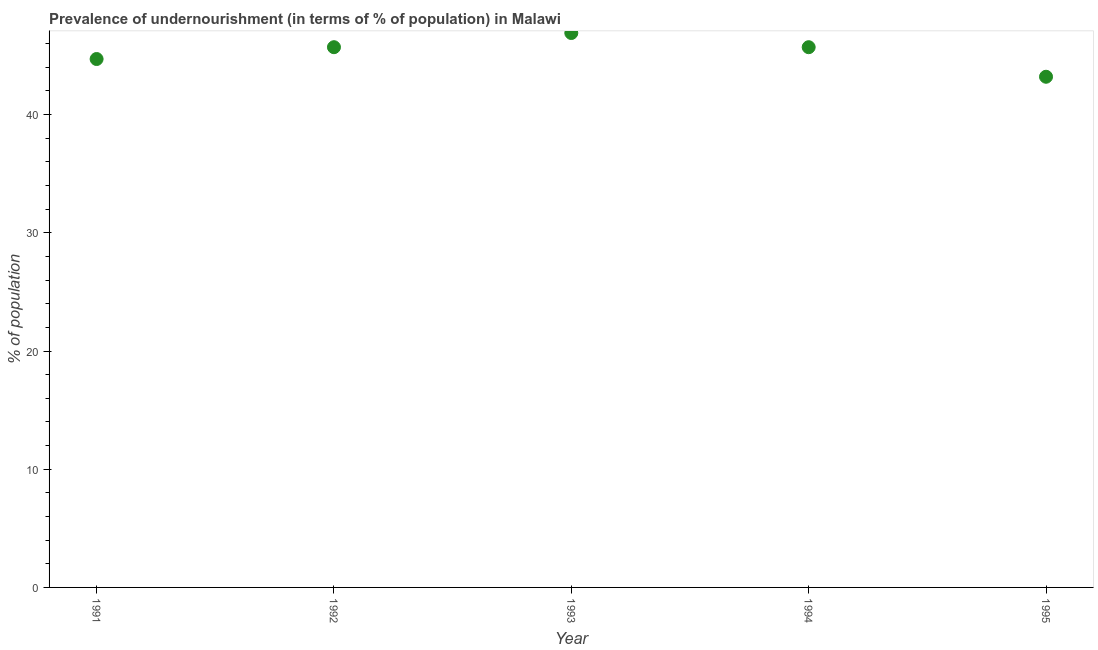What is the percentage of undernourished population in 1991?
Provide a succinct answer. 44.7. Across all years, what is the maximum percentage of undernourished population?
Offer a terse response. 46.9. Across all years, what is the minimum percentage of undernourished population?
Give a very brief answer. 43.2. In which year was the percentage of undernourished population maximum?
Offer a terse response. 1993. In which year was the percentage of undernourished population minimum?
Provide a short and direct response. 1995. What is the sum of the percentage of undernourished population?
Give a very brief answer. 226.2. What is the average percentage of undernourished population per year?
Provide a short and direct response. 45.24. What is the median percentage of undernourished population?
Give a very brief answer. 45.7. In how many years, is the percentage of undernourished population greater than 26 %?
Your response must be concise. 5. Do a majority of the years between 1992 and 1993 (inclusive) have percentage of undernourished population greater than 22 %?
Give a very brief answer. Yes. What is the ratio of the percentage of undernourished population in 1994 to that in 1995?
Provide a short and direct response. 1.06. Is the percentage of undernourished population in 1992 less than that in 1994?
Make the answer very short. No. Is the difference between the percentage of undernourished population in 1992 and 1994 greater than the difference between any two years?
Your answer should be compact. No. What is the difference between the highest and the second highest percentage of undernourished population?
Keep it short and to the point. 1.2. Is the sum of the percentage of undernourished population in 1993 and 1995 greater than the maximum percentage of undernourished population across all years?
Provide a succinct answer. Yes. What is the difference between the highest and the lowest percentage of undernourished population?
Provide a succinct answer. 3.7. How many dotlines are there?
Make the answer very short. 1. What is the difference between two consecutive major ticks on the Y-axis?
Your response must be concise. 10. Are the values on the major ticks of Y-axis written in scientific E-notation?
Make the answer very short. No. Does the graph contain grids?
Offer a very short reply. No. What is the title of the graph?
Ensure brevity in your answer.  Prevalence of undernourishment (in terms of % of population) in Malawi. What is the label or title of the Y-axis?
Your answer should be very brief. % of population. What is the % of population in 1991?
Give a very brief answer. 44.7. What is the % of population in 1992?
Keep it short and to the point. 45.7. What is the % of population in 1993?
Offer a very short reply. 46.9. What is the % of population in 1994?
Give a very brief answer. 45.7. What is the % of population in 1995?
Provide a short and direct response. 43.2. What is the difference between the % of population in 1991 and 1993?
Ensure brevity in your answer.  -2.2. What is the difference between the % of population in 1991 and 1994?
Make the answer very short. -1. What is the difference between the % of population in 1991 and 1995?
Your response must be concise. 1.5. What is the difference between the % of population in 1992 and 1994?
Make the answer very short. 0. What is the difference between the % of population in 1992 and 1995?
Provide a succinct answer. 2.5. What is the difference between the % of population in 1993 and 1994?
Your answer should be very brief. 1.2. What is the difference between the % of population in 1993 and 1995?
Your answer should be very brief. 3.7. What is the difference between the % of population in 1994 and 1995?
Offer a very short reply. 2.5. What is the ratio of the % of population in 1991 to that in 1992?
Offer a terse response. 0.98. What is the ratio of the % of population in 1991 to that in 1993?
Ensure brevity in your answer.  0.95. What is the ratio of the % of population in 1991 to that in 1994?
Keep it short and to the point. 0.98. What is the ratio of the % of population in 1991 to that in 1995?
Give a very brief answer. 1.03. What is the ratio of the % of population in 1992 to that in 1994?
Provide a short and direct response. 1. What is the ratio of the % of population in 1992 to that in 1995?
Give a very brief answer. 1.06. What is the ratio of the % of population in 1993 to that in 1994?
Your answer should be very brief. 1.03. What is the ratio of the % of population in 1993 to that in 1995?
Keep it short and to the point. 1.09. What is the ratio of the % of population in 1994 to that in 1995?
Your answer should be compact. 1.06. 